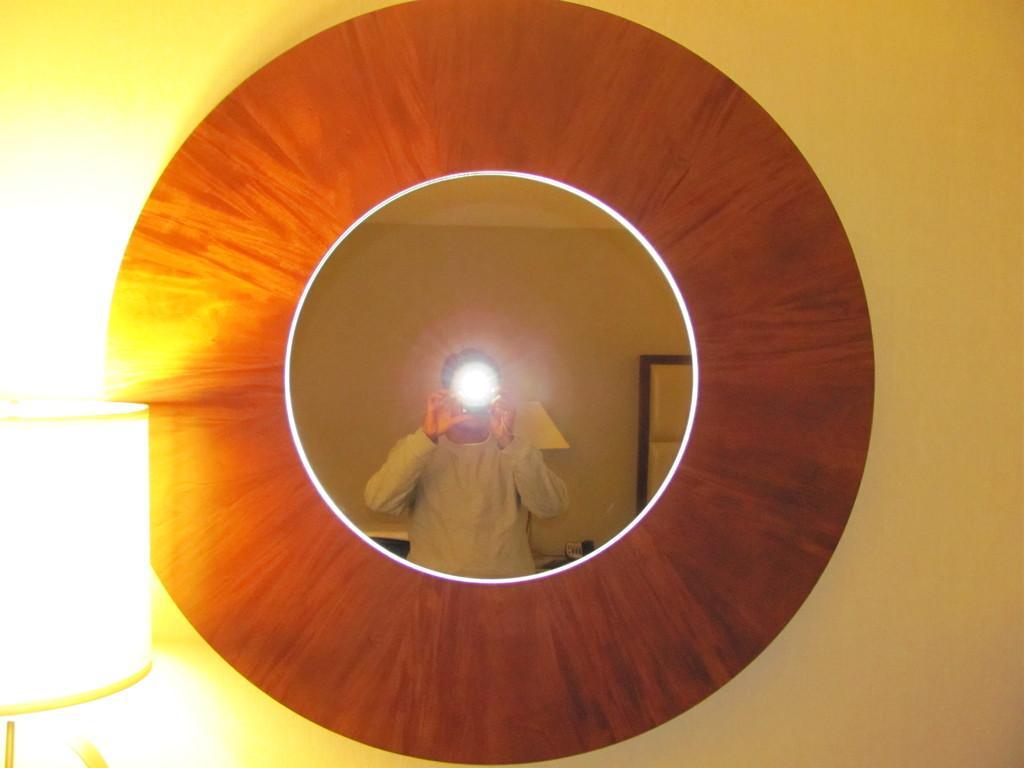In one or two sentences, can you explain what this image depicts? In this picture I can see a light on the left side, in the middle it looks like a mirror. There is a reflected image of a human on this mirror. 